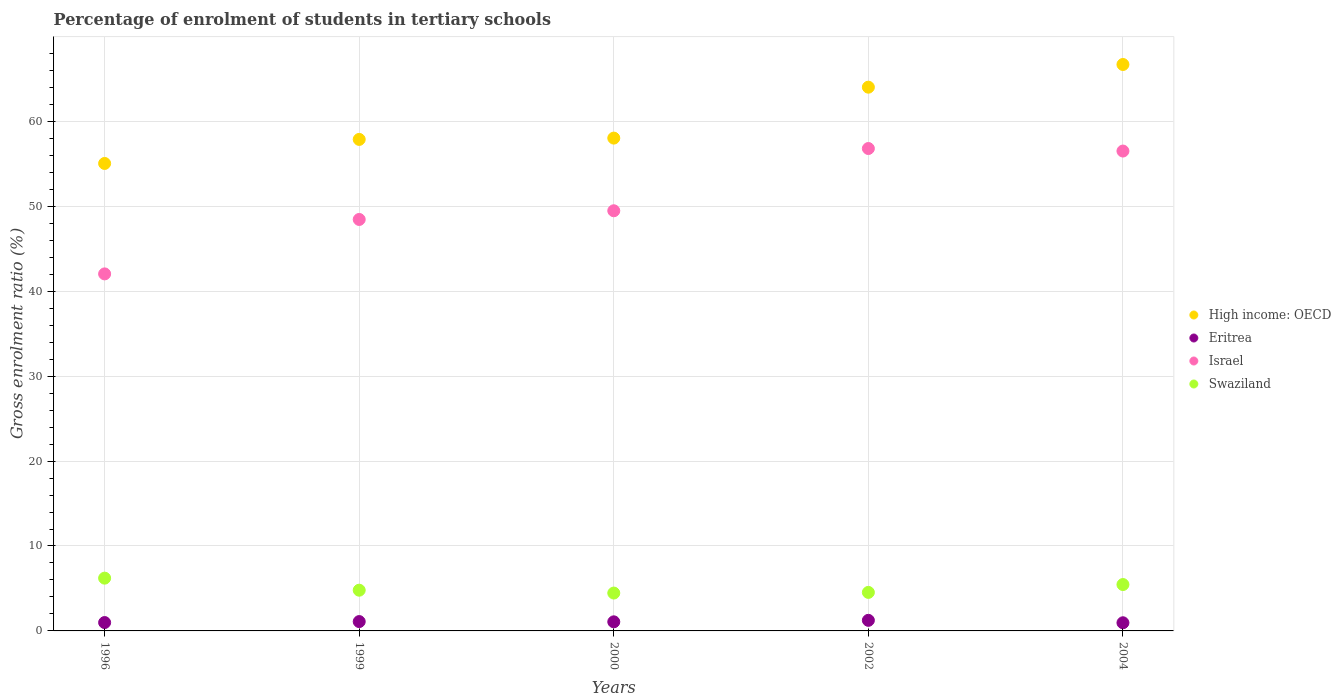How many different coloured dotlines are there?
Your answer should be very brief. 4. What is the percentage of students enrolled in tertiary schools in Eritrea in 2000?
Provide a succinct answer. 1.07. Across all years, what is the maximum percentage of students enrolled in tertiary schools in Israel?
Make the answer very short. 56.8. Across all years, what is the minimum percentage of students enrolled in tertiary schools in Swaziland?
Your answer should be compact. 4.46. In which year was the percentage of students enrolled in tertiary schools in High income: OECD maximum?
Offer a terse response. 2004. What is the total percentage of students enrolled in tertiary schools in Swaziland in the graph?
Provide a short and direct response. 25.47. What is the difference between the percentage of students enrolled in tertiary schools in High income: OECD in 2000 and that in 2002?
Your answer should be compact. -6. What is the difference between the percentage of students enrolled in tertiary schools in Swaziland in 2002 and the percentage of students enrolled in tertiary schools in High income: OECD in 1999?
Keep it short and to the point. -53.34. What is the average percentage of students enrolled in tertiary schools in Swaziland per year?
Offer a very short reply. 5.09. In the year 1996, what is the difference between the percentage of students enrolled in tertiary schools in Swaziland and percentage of students enrolled in tertiary schools in High income: OECD?
Your answer should be compact. -48.83. In how many years, is the percentage of students enrolled in tertiary schools in High income: OECD greater than 48 %?
Ensure brevity in your answer.  5. What is the ratio of the percentage of students enrolled in tertiary schools in Eritrea in 1996 to that in 2000?
Offer a terse response. 0.92. What is the difference between the highest and the second highest percentage of students enrolled in tertiary schools in Israel?
Provide a short and direct response. 0.3. What is the difference between the highest and the lowest percentage of students enrolled in tertiary schools in Israel?
Provide a succinct answer. 14.76. Is it the case that in every year, the sum of the percentage of students enrolled in tertiary schools in Israel and percentage of students enrolled in tertiary schools in Swaziland  is greater than the sum of percentage of students enrolled in tertiary schools in Eritrea and percentage of students enrolled in tertiary schools in High income: OECD?
Give a very brief answer. No. Is the percentage of students enrolled in tertiary schools in Israel strictly greater than the percentage of students enrolled in tertiary schools in High income: OECD over the years?
Make the answer very short. No. How many years are there in the graph?
Provide a short and direct response. 5. Does the graph contain any zero values?
Make the answer very short. No. Does the graph contain grids?
Provide a short and direct response. Yes. How many legend labels are there?
Make the answer very short. 4. What is the title of the graph?
Your response must be concise. Percentage of enrolment of students in tertiary schools. Does "World" appear as one of the legend labels in the graph?
Your response must be concise. No. What is the label or title of the X-axis?
Provide a short and direct response. Years. What is the Gross enrolment ratio (%) in High income: OECD in 1996?
Provide a succinct answer. 55.04. What is the Gross enrolment ratio (%) in Eritrea in 1996?
Ensure brevity in your answer.  0.99. What is the Gross enrolment ratio (%) of Israel in 1996?
Your answer should be compact. 42.04. What is the Gross enrolment ratio (%) in Swaziland in 1996?
Your response must be concise. 6.21. What is the Gross enrolment ratio (%) of High income: OECD in 1999?
Ensure brevity in your answer.  57.87. What is the Gross enrolment ratio (%) in Eritrea in 1999?
Provide a short and direct response. 1.1. What is the Gross enrolment ratio (%) in Israel in 1999?
Keep it short and to the point. 48.45. What is the Gross enrolment ratio (%) in Swaziland in 1999?
Give a very brief answer. 4.79. What is the Gross enrolment ratio (%) of High income: OECD in 2000?
Provide a succinct answer. 58.03. What is the Gross enrolment ratio (%) of Eritrea in 2000?
Ensure brevity in your answer.  1.07. What is the Gross enrolment ratio (%) in Israel in 2000?
Offer a terse response. 49.47. What is the Gross enrolment ratio (%) of Swaziland in 2000?
Ensure brevity in your answer.  4.46. What is the Gross enrolment ratio (%) of High income: OECD in 2002?
Your answer should be very brief. 64.02. What is the Gross enrolment ratio (%) in Eritrea in 2002?
Provide a succinct answer. 1.25. What is the Gross enrolment ratio (%) of Israel in 2002?
Give a very brief answer. 56.8. What is the Gross enrolment ratio (%) in Swaziland in 2002?
Your response must be concise. 4.54. What is the Gross enrolment ratio (%) of High income: OECD in 2004?
Make the answer very short. 66.69. What is the Gross enrolment ratio (%) of Eritrea in 2004?
Your answer should be very brief. 0.96. What is the Gross enrolment ratio (%) of Israel in 2004?
Ensure brevity in your answer.  56.5. What is the Gross enrolment ratio (%) of Swaziland in 2004?
Your response must be concise. 5.46. Across all years, what is the maximum Gross enrolment ratio (%) in High income: OECD?
Your answer should be very brief. 66.69. Across all years, what is the maximum Gross enrolment ratio (%) of Eritrea?
Provide a short and direct response. 1.25. Across all years, what is the maximum Gross enrolment ratio (%) of Israel?
Ensure brevity in your answer.  56.8. Across all years, what is the maximum Gross enrolment ratio (%) in Swaziland?
Give a very brief answer. 6.21. Across all years, what is the minimum Gross enrolment ratio (%) of High income: OECD?
Provide a short and direct response. 55.04. Across all years, what is the minimum Gross enrolment ratio (%) in Eritrea?
Offer a terse response. 0.96. Across all years, what is the minimum Gross enrolment ratio (%) of Israel?
Your answer should be compact. 42.04. Across all years, what is the minimum Gross enrolment ratio (%) of Swaziland?
Give a very brief answer. 4.46. What is the total Gross enrolment ratio (%) in High income: OECD in the graph?
Provide a short and direct response. 301.66. What is the total Gross enrolment ratio (%) in Eritrea in the graph?
Keep it short and to the point. 5.36. What is the total Gross enrolment ratio (%) of Israel in the graph?
Ensure brevity in your answer.  253.26. What is the total Gross enrolment ratio (%) of Swaziland in the graph?
Your response must be concise. 25.47. What is the difference between the Gross enrolment ratio (%) in High income: OECD in 1996 and that in 1999?
Offer a very short reply. -2.83. What is the difference between the Gross enrolment ratio (%) of Eritrea in 1996 and that in 1999?
Your answer should be very brief. -0.12. What is the difference between the Gross enrolment ratio (%) in Israel in 1996 and that in 1999?
Your answer should be compact. -6.41. What is the difference between the Gross enrolment ratio (%) of Swaziland in 1996 and that in 1999?
Provide a short and direct response. 1.42. What is the difference between the Gross enrolment ratio (%) in High income: OECD in 1996 and that in 2000?
Provide a short and direct response. -2.99. What is the difference between the Gross enrolment ratio (%) in Eritrea in 1996 and that in 2000?
Ensure brevity in your answer.  -0.09. What is the difference between the Gross enrolment ratio (%) in Israel in 1996 and that in 2000?
Your answer should be very brief. -7.43. What is the difference between the Gross enrolment ratio (%) in Swaziland in 1996 and that in 2000?
Make the answer very short. 1.75. What is the difference between the Gross enrolment ratio (%) of High income: OECD in 1996 and that in 2002?
Give a very brief answer. -8.98. What is the difference between the Gross enrolment ratio (%) of Eritrea in 1996 and that in 2002?
Provide a succinct answer. -0.26. What is the difference between the Gross enrolment ratio (%) of Israel in 1996 and that in 2002?
Give a very brief answer. -14.76. What is the difference between the Gross enrolment ratio (%) of Swaziland in 1996 and that in 2002?
Your answer should be compact. 1.68. What is the difference between the Gross enrolment ratio (%) of High income: OECD in 1996 and that in 2004?
Offer a terse response. -11.65. What is the difference between the Gross enrolment ratio (%) of Eritrea in 1996 and that in 2004?
Provide a succinct answer. 0.03. What is the difference between the Gross enrolment ratio (%) of Israel in 1996 and that in 2004?
Offer a terse response. -14.46. What is the difference between the Gross enrolment ratio (%) of Swaziland in 1996 and that in 2004?
Keep it short and to the point. 0.75. What is the difference between the Gross enrolment ratio (%) in High income: OECD in 1999 and that in 2000?
Ensure brevity in your answer.  -0.15. What is the difference between the Gross enrolment ratio (%) of Eritrea in 1999 and that in 2000?
Give a very brief answer. 0.03. What is the difference between the Gross enrolment ratio (%) of Israel in 1999 and that in 2000?
Your answer should be compact. -1.02. What is the difference between the Gross enrolment ratio (%) of Swaziland in 1999 and that in 2000?
Ensure brevity in your answer.  0.34. What is the difference between the Gross enrolment ratio (%) of High income: OECD in 1999 and that in 2002?
Your answer should be compact. -6.15. What is the difference between the Gross enrolment ratio (%) in Eritrea in 1999 and that in 2002?
Provide a succinct answer. -0.15. What is the difference between the Gross enrolment ratio (%) in Israel in 1999 and that in 2002?
Your response must be concise. -8.35. What is the difference between the Gross enrolment ratio (%) of Swaziland in 1999 and that in 2002?
Your response must be concise. 0.26. What is the difference between the Gross enrolment ratio (%) of High income: OECD in 1999 and that in 2004?
Make the answer very short. -8.82. What is the difference between the Gross enrolment ratio (%) of Eritrea in 1999 and that in 2004?
Offer a very short reply. 0.14. What is the difference between the Gross enrolment ratio (%) in Israel in 1999 and that in 2004?
Give a very brief answer. -8.06. What is the difference between the Gross enrolment ratio (%) in Swaziland in 1999 and that in 2004?
Your answer should be compact. -0.67. What is the difference between the Gross enrolment ratio (%) in High income: OECD in 2000 and that in 2002?
Your answer should be very brief. -6. What is the difference between the Gross enrolment ratio (%) of Eritrea in 2000 and that in 2002?
Provide a succinct answer. -0.18. What is the difference between the Gross enrolment ratio (%) of Israel in 2000 and that in 2002?
Your answer should be compact. -7.33. What is the difference between the Gross enrolment ratio (%) in Swaziland in 2000 and that in 2002?
Provide a short and direct response. -0.08. What is the difference between the Gross enrolment ratio (%) of High income: OECD in 2000 and that in 2004?
Give a very brief answer. -8.67. What is the difference between the Gross enrolment ratio (%) of Eritrea in 2000 and that in 2004?
Provide a short and direct response. 0.11. What is the difference between the Gross enrolment ratio (%) of Israel in 2000 and that in 2004?
Provide a succinct answer. -7.03. What is the difference between the Gross enrolment ratio (%) of Swaziland in 2000 and that in 2004?
Provide a short and direct response. -1. What is the difference between the Gross enrolment ratio (%) of High income: OECD in 2002 and that in 2004?
Make the answer very short. -2.67. What is the difference between the Gross enrolment ratio (%) of Eritrea in 2002 and that in 2004?
Provide a succinct answer. 0.29. What is the difference between the Gross enrolment ratio (%) in Israel in 2002 and that in 2004?
Provide a succinct answer. 0.3. What is the difference between the Gross enrolment ratio (%) in Swaziland in 2002 and that in 2004?
Provide a succinct answer. -0.93. What is the difference between the Gross enrolment ratio (%) of High income: OECD in 1996 and the Gross enrolment ratio (%) of Eritrea in 1999?
Ensure brevity in your answer.  53.94. What is the difference between the Gross enrolment ratio (%) of High income: OECD in 1996 and the Gross enrolment ratio (%) of Israel in 1999?
Your answer should be compact. 6.59. What is the difference between the Gross enrolment ratio (%) of High income: OECD in 1996 and the Gross enrolment ratio (%) of Swaziland in 1999?
Your answer should be very brief. 50.25. What is the difference between the Gross enrolment ratio (%) in Eritrea in 1996 and the Gross enrolment ratio (%) in Israel in 1999?
Ensure brevity in your answer.  -47.46. What is the difference between the Gross enrolment ratio (%) of Eritrea in 1996 and the Gross enrolment ratio (%) of Swaziland in 1999?
Provide a short and direct response. -3.81. What is the difference between the Gross enrolment ratio (%) in Israel in 1996 and the Gross enrolment ratio (%) in Swaziland in 1999?
Your response must be concise. 37.24. What is the difference between the Gross enrolment ratio (%) of High income: OECD in 1996 and the Gross enrolment ratio (%) of Eritrea in 2000?
Give a very brief answer. 53.97. What is the difference between the Gross enrolment ratio (%) in High income: OECD in 1996 and the Gross enrolment ratio (%) in Israel in 2000?
Provide a short and direct response. 5.57. What is the difference between the Gross enrolment ratio (%) of High income: OECD in 1996 and the Gross enrolment ratio (%) of Swaziland in 2000?
Give a very brief answer. 50.58. What is the difference between the Gross enrolment ratio (%) of Eritrea in 1996 and the Gross enrolment ratio (%) of Israel in 2000?
Your answer should be very brief. -48.49. What is the difference between the Gross enrolment ratio (%) in Eritrea in 1996 and the Gross enrolment ratio (%) in Swaziland in 2000?
Your answer should be compact. -3.47. What is the difference between the Gross enrolment ratio (%) of Israel in 1996 and the Gross enrolment ratio (%) of Swaziland in 2000?
Offer a terse response. 37.58. What is the difference between the Gross enrolment ratio (%) in High income: OECD in 1996 and the Gross enrolment ratio (%) in Eritrea in 2002?
Make the answer very short. 53.8. What is the difference between the Gross enrolment ratio (%) in High income: OECD in 1996 and the Gross enrolment ratio (%) in Israel in 2002?
Ensure brevity in your answer.  -1.76. What is the difference between the Gross enrolment ratio (%) in High income: OECD in 1996 and the Gross enrolment ratio (%) in Swaziland in 2002?
Give a very brief answer. 50.51. What is the difference between the Gross enrolment ratio (%) of Eritrea in 1996 and the Gross enrolment ratio (%) of Israel in 2002?
Give a very brief answer. -55.82. What is the difference between the Gross enrolment ratio (%) of Eritrea in 1996 and the Gross enrolment ratio (%) of Swaziland in 2002?
Provide a succinct answer. -3.55. What is the difference between the Gross enrolment ratio (%) in Israel in 1996 and the Gross enrolment ratio (%) in Swaziland in 2002?
Your answer should be compact. 37.5. What is the difference between the Gross enrolment ratio (%) of High income: OECD in 1996 and the Gross enrolment ratio (%) of Eritrea in 2004?
Offer a very short reply. 54.08. What is the difference between the Gross enrolment ratio (%) in High income: OECD in 1996 and the Gross enrolment ratio (%) in Israel in 2004?
Your answer should be compact. -1.46. What is the difference between the Gross enrolment ratio (%) of High income: OECD in 1996 and the Gross enrolment ratio (%) of Swaziland in 2004?
Keep it short and to the point. 49.58. What is the difference between the Gross enrolment ratio (%) in Eritrea in 1996 and the Gross enrolment ratio (%) in Israel in 2004?
Your answer should be compact. -55.52. What is the difference between the Gross enrolment ratio (%) of Eritrea in 1996 and the Gross enrolment ratio (%) of Swaziland in 2004?
Your answer should be very brief. -4.48. What is the difference between the Gross enrolment ratio (%) of Israel in 1996 and the Gross enrolment ratio (%) of Swaziland in 2004?
Offer a very short reply. 36.58. What is the difference between the Gross enrolment ratio (%) in High income: OECD in 1999 and the Gross enrolment ratio (%) in Eritrea in 2000?
Give a very brief answer. 56.8. What is the difference between the Gross enrolment ratio (%) in High income: OECD in 1999 and the Gross enrolment ratio (%) in Israel in 2000?
Your answer should be compact. 8.4. What is the difference between the Gross enrolment ratio (%) of High income: OECD in 1999 and the Gross enrolment ratio (%) of Swaziland in 2000?
Give a very brief answer. 53.41. What is the difference between the Gross enrolment ratio (%) of Eritrea in 1999 and the Gross enrolment ratio (%) of Israel in 2000?
Keep it short and to the point. -48.37. What is the difference between the Gross enrolment ratio (%) of Eritrea in 1999 and the Gross enrolment ratio (%) of Swaziland in 2000?
Your answer should be very brief. -3.36. What is the difference between the Gross enrolment ratio (%) in Israel in 1999 and the Gross enrolment ratio (%) in Swaziland in 2000?
Your answer should be very brief. 43.99. What is the difference between the Gross enrolment ratio (%) in High income: OECD in 1999 and the Gross enrolment ratio (%) in Eritrea in 2002?
Your answer should be compact. 56.63. What is the difference between the Gross enrolment ratio (%) of High income: OECD in 1999 and the Gross enrolment ratio (%) of Israel in 2002?
Offer a terse response. 1.07. What is the difference between the Gross enrolment ratio (%) of High income: OECD in 1999 and the Gross enrolment ratio (%) of Swaziland in 2002?
Offer a very short reply. 53.34. What is the difference between the Gross enrolment ratio (%) of Eritrea in 1999 and the Gross enrolment ratio (%) of Israel in 2002?
Provide a short and direct response. -55.7. What is the difference between the Gross enrolment ratio (%) of Eritrea in 1999 and the Gross enrolment ratio (%) of Swaziland in 2002?
Keep it short and to the point. -3.44. What is the difference between the Gross enrolment ratio (%) of Israel in 1999 and the Gross enrolment ratio (%) of Swaziland in 2002?
Provide a succinct answer. 43.91. What is the difference between the Gross enrolment ratio (%) of High income: OECD in 1999 and the Gross enrolment ratio (%) of Eritrea in 2004?
Provide a short and direct response. 56.91. What is the difference between the Gross enrolment ratio (%) in High income: OECD in 1999 and the Gross enrolment ratio (%) in Israel in 2004?
Your answer should be very brief. 1.37. What is the difference between the Gross enrolment ratio (%) of High income: OECD in 1999 and the Gross enrolment ratio (%) of Swaziland in 2004?
Your response must be concise. 52.41. What is the difference between the Gross enrolment ratio (%) in Eritrea in 1999 and the Gross enrolment ratio (%) in Israel in 2004?
Your response must be concise. -55.4. What is the difference between the Gross enrolment ratio (%) in Eritrea in 1999 and the Gross enrolment ratio (%) in Swaziland in 2004?
Provide a succinct answer. -4.36. What is the difference between the Gross enrolment ratio (%) of Israel in 1999 and the Gross enrolment ratio (%) of Swaziland in 2004?
Provide a succinct answer. 42.99. What is the difference between the Gross enrolment ratio (%) of High income: OECD in 2000 and the Gross enrolment ratio (%) of Eritrea in 2002?
Make the answer very short. 56.78. What is the difference between the Gross enrolment ratio (%) in High income: OECD in 2000 and the Gross enrolment ratio (%) in Israel in 2002?
Give a very brief answer. 1.23. What is the difference between the Gross enrolment ratio (%) in High income: OECD in 2000 and the Gross enrolment ratio (%) in Swaziland in 2002?
Your answer should be compact. 53.49. What is the difference between the Gross enrolment ratio (%) in Eritrea in 2000 and the Gross enrolment ratio (%) in Israel in 2002?
Provide a succinct answer. -55.73. What is the difference between the Gross enrolment ratio (%) of Eritrea in 2000 and the Gross enrolment ratio (%) of Swaziland in 2002?
Give a very brief answer. -3.47. What is the difference between the Gross enrolment ratio (%) of Israel in 2000 and the Gross enrolment ratio (%) of Swaziland in 2002?
Offer a very short reply. 44.94. What is the difference between the Gross enrolment ratio (%) of High income: OECD in 2000 and the Gross enrolment ratio (%) of Eritrea in 2004?
Your answer should be compact. 57.07. What is the difference between the Gross enrolment ratio (%) in High income: OECD in 2000 and the Gross enrolment ratio (%) in Israel in 2004?
Offer a terse response. 1.52. What is the difference between the Gross enrolment ratio (%) in High income: OECD in 2000 and the Gross enrolment ratio (%) in Swaziland in 2004?
Provide a succinct answer. 52.57. What is the difference between the Gross enrolment ratio (%) in Eritrea in 2000 and the Gross enrolment ratio (%) in Israel in 2004?
Offer a terse response. -55.43. What is the difference between the Gross enrolment ratio (%) in Eritrea in 2000 and the Gross enrolment ratio (%) in Swaziland in 2004?
Offer a terse response. -4.39. What is the difference between the Gross enrolment ratio (%) of Israel in 2000 and the Gross enrolment ratio (%) of Swaziland in 2004?
Provide a short and direct response. 44.01. What is the difference between the Gross enrolment ratio (%) of High income: OECD in 2002 and the Gross enrolment ratio (%) of Eritrea in 2004?
Your answer should be very brief. 63.06. What is the difference between the Gross enrolment ratio (%) in High income: OECD in 2002 and the Gross enrolment ratio (%) in Israel in 2004?
Keep it short and to the point. 7.52. What is the difference between the Gross enrolment ratio (%) of High income: OECD in 2002 and the Gross enrolment ratio (%) of Swaziland in 2004?
Your answer should be compact. 58.56. What is the difference between the Gross enrolment ratio (%) of Eritrea in 2002 and the Gross enrolment ratio (%) of Israel in 2004?
Provide a short and direct response. -55.26. What is the difference between the Gross enrolment ratio (%) of Eritrea in 2002 and the Gross enrolment ratio (%) of Swaziland in 2004?
Your answer should be very brief. -4.21. What is the difference between the Gross enrolment ratio (%) of Israel in 2002 and the Gross enrolment ratio (%) of Swaziland in 2004?
Ensure brevity in your answer.  51.34. What is the average Gross enrolment ratio (%) in High income: OECD per year?
Your answer should be compact. 60.33. What is the average Gross enrolment ratio (%) of Eritrea per year?
Give a very brief answer. 1.07. What is the average Gross enrolment ratio (%) in Israel per year?
Provide a short and direct response. 50.65. What is the average Gross enrolment ratio (%) in Swaziland per year?
Your response must be concise. 5.09. In the year 1996, what is the difference between the Gross enrolment ratio (%) of High income: OECD and Gross enrolment ratio (%) of Eritrea?
Give a very brief answer. 54.06. In the year 1996, what is the difference between the Gross enrolment ratio (%) in High income: OECD and Gross enrolment ratio (%) in Israel?
Ensure brevity in your answer.  13. In the year 1996, what is the difference between the Gross enrolment ratio (%) of High income: OECD and Gross enrolment ratio (%) of Swaziland?
Give a very brief answer. 48.83. In the year 1996, what is the difference between the Gross enrolment ratio (%) of Eritrea and Gross enrolment ratio (%) of Israel?
Your answer should be very brief. -41.05. In the year 1996, what is the difference between the Gross enrolment ratio (%) in Eritrea and Gross enrolment ratio (%) in Swaziland?
Keep it short and to the point. -5.23. In the year 1996, what is the difference between the Gross enrolment ratio (%) in Israel and Gross enrolment ratio (%) in Swaziland?
Give a very brief answer. 35.82. In the year 1999, what is the difference between the Gross enrolment ratio (%) of High income: OECD and Gross enrolment ratio (%) of Eritrea?
Provide a succinct answer. 56.77. In the year 1999, what is the difference between the Gross enrolment ratio (%) in High income: OECD and Gross enrolment ratio (%) in Israel?
Provide a short and direct response. 9.43. In the year 1999, what is the difference between the Gross enrolment ratio (%) of High income: OECD and Gross enrolment ratio (%) of Swaziland?
Your response must be concise. 53.08. In the year 1999, what is the difference between the Gross enrolment ratio (%) of Eritrea and Gross enrolment ratio (%) of Israel?
Provide a short and direct response. -47.35. In the year 1999, what is the difference between the Gross enrolment ratio (%) of Eritrea and Gross enrolment ratio (%) of Swaziland?
Ensure brevity in your answer.  -3.69. In the year 1999, what is the difference between the Gross enrolment ratio (%) in Israel and Gross enrolment ratio (%) in Swaziland?
Your answer should be very brief. 43.65. In the year 2000, what is the difference between the Gross enrolment ratio (%) in High income: OECD and Gross enrolment ratio (%) in Eritrea?
Give a very brief answer. 56.96. In the year 2000, what is the difference between the Gross enrolment ratio (%) in High income: OECD and Gross enrolment ratio (%) in Israel?
Make the answer very short. 8.56. In the year 2000, what is the difference between the Gross enrolment ratio (%) of High income: OECD and Gross enrolment ratio (%) of Swaziland?
Provide a succinct answer. 53.57. In the year 2000, what is the difference between the Gross enrolment ratio (%) of Eritrea and Gross enrolment ratio (%) of Israel?
Offer a very short reply. -48.4. In the year 2000, what is the difference between the Gross enrolment ratio (%) in Eritrea and Gross enrolment ratio (%) in Swaziland?
Keep it short and to the point. -3.39. In the year 2000, what is the difference between the Gross enrolment ratio (%) in Israel and Gross enrolment ratio (%) in Swaziland?
Make the answer very short. 45.01. In the year 2002, what is the difference between the Gross enrolment ratio (%) of High income: OECD and Gross enrolment ratio (%) of Eritrea?
Provide a succinct answer. 62.78. In the year 2002, what is the difference between the Gross enrolment ratio (%) in High income: OECD and Gross enrolment ratio (%) in Israel?
Provide a succinct answer. 7.22. In the year 2002, what is the difference between the Gross enrolment ratio (%) in High income: OECD and Gross enrolment ratio (%) in Swaziland?
Your response must be concise. 59.49. In the year 2002, what is the difference between the Gross enrolment ratio (%) of Eritrea and Gross enrolment ratio (%) of Israel?
Provide a succinct answer. -55.55. In the year 2002, what is the difference between the Gross enrolment ratio (%) of Eritrea and Gross enrolment ratio (%) of Swaziland?
Your response must be concise. -3.29. In the year 2002, what is the difference between the Gross enrolment ratio (%) of Israel and Gross enrolment ratio (%) of Swaziland?
Keep it short and to the point. 52.26. In the year 2004, what is the difference between the Gross enrolment ratio (%) of High income: OECD and Gross enrolment ratio (%) of Eritrea?
Your answer should be very brief. 65.74. In the year 2004, what is the difference between the Gross enrolment ratio (%) of High income: OECD and Gross enrolment ratio (%) of Israel?
Your answer should be very brief. 10.19. In the year 2004, what is the difference between the Gross enrolment ratio (%) of High income: OECD and Gross enrolment ratio (%) of Swaziland?
Offer a terse response. 61.23. In the year 2004, what is the difference between the Gross enrolment ratio (%) of Eritrea and Gross enrolment ratio (%) of Israel?
Your response must be concise. -55.54. In the year 2004, what is the difference between the Gross enrolment ratio (%) of Eritrea and Gross enrolment ratio (%) of Swaziland?
Your answer should be compact. -4.5. In the year 2004, what is the difference between the Gross enrolment ratio (%) in Israel and Gross enrolment ratio (%) in Swaziland?
Provide a succinct answer. 51.04. What is the ratio of the Gross enrolment ratio (%) in High income: OECD in 1996 to that in 1999?
Offer a very short reply. 0.95. What is the ratio of the Gross enrolment ratio (%) of Eritrea in 1996 to that in 1999?
Ensure brevity in your answer.  0.9. What is the ratio of the Gross enrolment ratio (%) of Israel in 1996 to that in 1999?
Your response must be concise. 0.87. What is the ratio of the Gross enrolment ratio (%) of Swaziland in 1996 to that in 1999?
Give a very brief answer. 1.3. What is the ratio of the Gross enrolment ratio (%) in High income: OECD in 1996 to that in 2000?
Provide a short and direct response. 0.95. What is the ratio of the Gross enrolment ratio (%) in Eritrea in 1996 to that in 2000?
Make the answer very short. 0.92. What is the ratio of the Gross enrolment ratio (%) of Israel in 1996 to that in 2000?
Provide a short and direct response. 0.85. What is the ratio of the Gross enrolment ratio (%) of Swaziland in 1996 to that in 2000?
Give a very brief answer. 1.39. What is the ratio of the Gross enrolment ratio (%) of High income: OECD in 1996 to that in 2002?
Ensure brevity in your answer.  0.86. What is the ratio of the Gross enrolment ratio (%) in Eritrea in 1996 to that in 2002?
Your answer should be compact. 0.79. What is the ratio of the Gross enrolment ratio (%) of Israel in 1996 to that in 2002?
Keep it short and to the point. 0.74. What is the ratio of the Gross enrolment ratio (%) in Swaziland in 1996 to that in 2002?
Provide a succinct answer. 1.37. What is the ratio of the Gross enrolment ratio (%) of High income: OECD in 1996 to that in 2004?
Your answer should be compact. 0.83. What is the ratio of the Gross enrolment ratio (%) of Eritrea in 1996 to that in 2004?
Keep it short and to the point. 1.03. What is the ratio of the Gross enrolment ratio (%) of Israel in 1996 to that in 2004?
Your answer should be compact. 0.74. What is the ratio of the Gross enrolment ratio (%) in Swaziland in 1996 to that in 2004?
Ensure brevity in your answer.  1.14. What is the ratio of the Gross enrolment ratio (%) in Eritrea in 1999 to that in 2000?
Provide a succinct answer. 1.03. What is the ratio of the Gross enrolment ratio (%) of Israel in 1999 to that in 2000?
Provide a succinct answer. 0.98. What is the ratio of the Gross enrolment ratio (%) in Swaziland in 1999 to that in 2000?
Offer a terse response. 1.08. What is the ratio of the Gross enrolment ratio (%) in High income: OECD in 1999 to that in 2002?
Offer a terse response. 0.9. What is the ratio of the Gross enrolment ratio (%) of Eritrea in 1999 to that in 2002?
Offer a very short reply. 0.88. What is the ratio of the Gross enrolment ratio (%) of Israel in 1999 to that in 2002?
Make the answer very short. 0.85. What is the ratio of the Gross enrolment ratio (%) in Swaziland in 1999 to that in 2002?
Your answer should be compact. 1.06. What is the ratio of the Gross enrolment ratio (%) in High income: OECD in 1999 to that in 2004?
Your answer should be compact. 0.87. What is the ratio of the Gross enrolment ratio (%) of Eritrea in 1999 to that in 2004?
Keep it short and to the point. 1.15. What is the ratio of the Gross enrolment ratio (%) in Israel in 1999 to that in 2004?
Ensure brevity in your answer.  0.86. What is the ratio of the Gross enrolment ratio (%) of Swaziland in 1999 to that in 2004?
Offer a very short reply. 0.88. What is the ratio of the Gross enrolment ratio (%) of High income: OECD in 2000 to that in 2002?
Give a very brief answer. 0.91. What is the ratio of the Gross enrolment ratio (%) of Eritrea in 2000 to that in 2002?
Give a very brief answer. 0.86. What is the ratio of the Gross enrolment ratio (%) in Israel in 2000 to that in 2002?
Give a very brief answer. 0.87. What is the ratio of the Gross enrolment ratio (%) in High income: OECD in 2000 to that in 2004?
Ensure brevity in your answer.  0.87. What is the ratio of the Gross enrolment ratio (%) in Eritrea in 2000 to that in 2004?
Keep it short and to the point. 1.12. What is the ratio of the Gross enrolment ratio (%) in Israel in 2000 to that in 2004?
Your response must be concise. 0.88. What is the ratio of the Gross enrolment ratio (%) in Swaziland in 2000 to that in 2004?
Ensure brevity in your answer.  0.82. What is the ratio of the Gross enrolment ratio (%) in High income: OECD in 2002 to that in 2004?
Give a very brief answer. 0.96. What is the ratio of the Gross enrolment ratio (%) in Eritrea in 2002 to that in 2004?
Offer a very short reply. 1.3. What is the ratio of the Gross enrolment ratio (%) of Israel in 2002 to that in 2004?
Your response must be concise. 1.01. What is the ratio of the Gross enrolment ratio (%) in Swaziland in 2002 to that in 2004?
Ensure brevity in your answer.  0.83. What is the difference between the highest and the second highest Gross enrolment ratio (%) in High income: OECD?
Keep it short and to the point. 2.67. What is the difference between the highest and the second highest Gross enrolment ratio (%) of Eritrea?
Provide a short and direct response. 0.15. What is the difference between the highest and the second highest Gross enrolment ratio (%) of Israel?
Give a very brief answer. 0.3. What is the difference between the highest and the second highest Gross enrolment ratio (%) in Swaziland?
Keep it short and to the point. 0.75. What is the difference between the highest and the lowest Gross enrolment ratio (%) of High income: OECD?
Your answer should be very brief. 11.65. What is the difference between the highest and the lowest Gross enrolment ratio (%) of Eritrea?
Ensure brevity in your answer.  0.29. What is the difference between the highest and the lowest Gross enrolment ratio (%) in Israel?
Ensure brevity in your answer.  14.76. What is the difference between the highest and the lowest Gross enrolment ratio (%) in Swaziland?
Offer a terse response. 1.75. 